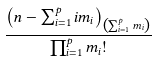<formula> <loc_0><loc_0><loc_500><loc_500>\frac { \left ( n - \sum _ { i = 1 } ^ { p } i m _ { i } \right ) _ { \left ( \sum _ { i = 1 } ^ { p } m _ { i } \right ) } } { \prod _ { i = 1 } ^ { p } m _ { i } ! }</formula> 